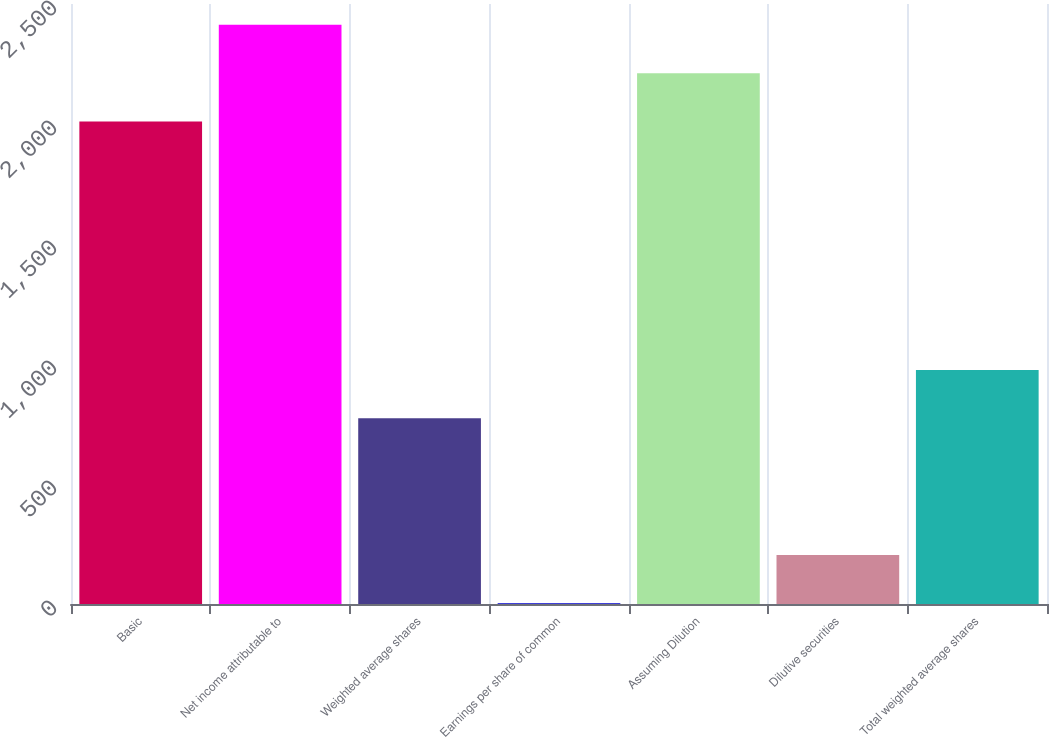<chart> <loc_0><loc_0><loc_500><loc_500><bar_chart><fcel>Basic<fcel>Net income attributable to<fcel>Weighted average shares<fcel>Earnings per share of common<fcel>Assuming Dilution<fcel>Dilutive securities<fcel>Total weighted average shares<nl><fcel>2010<fcel>2413.88<fcel>773.5<fcel>2.61<fcel>2211.94<fcel>204.55<fcel>975.44<nl></chart> 